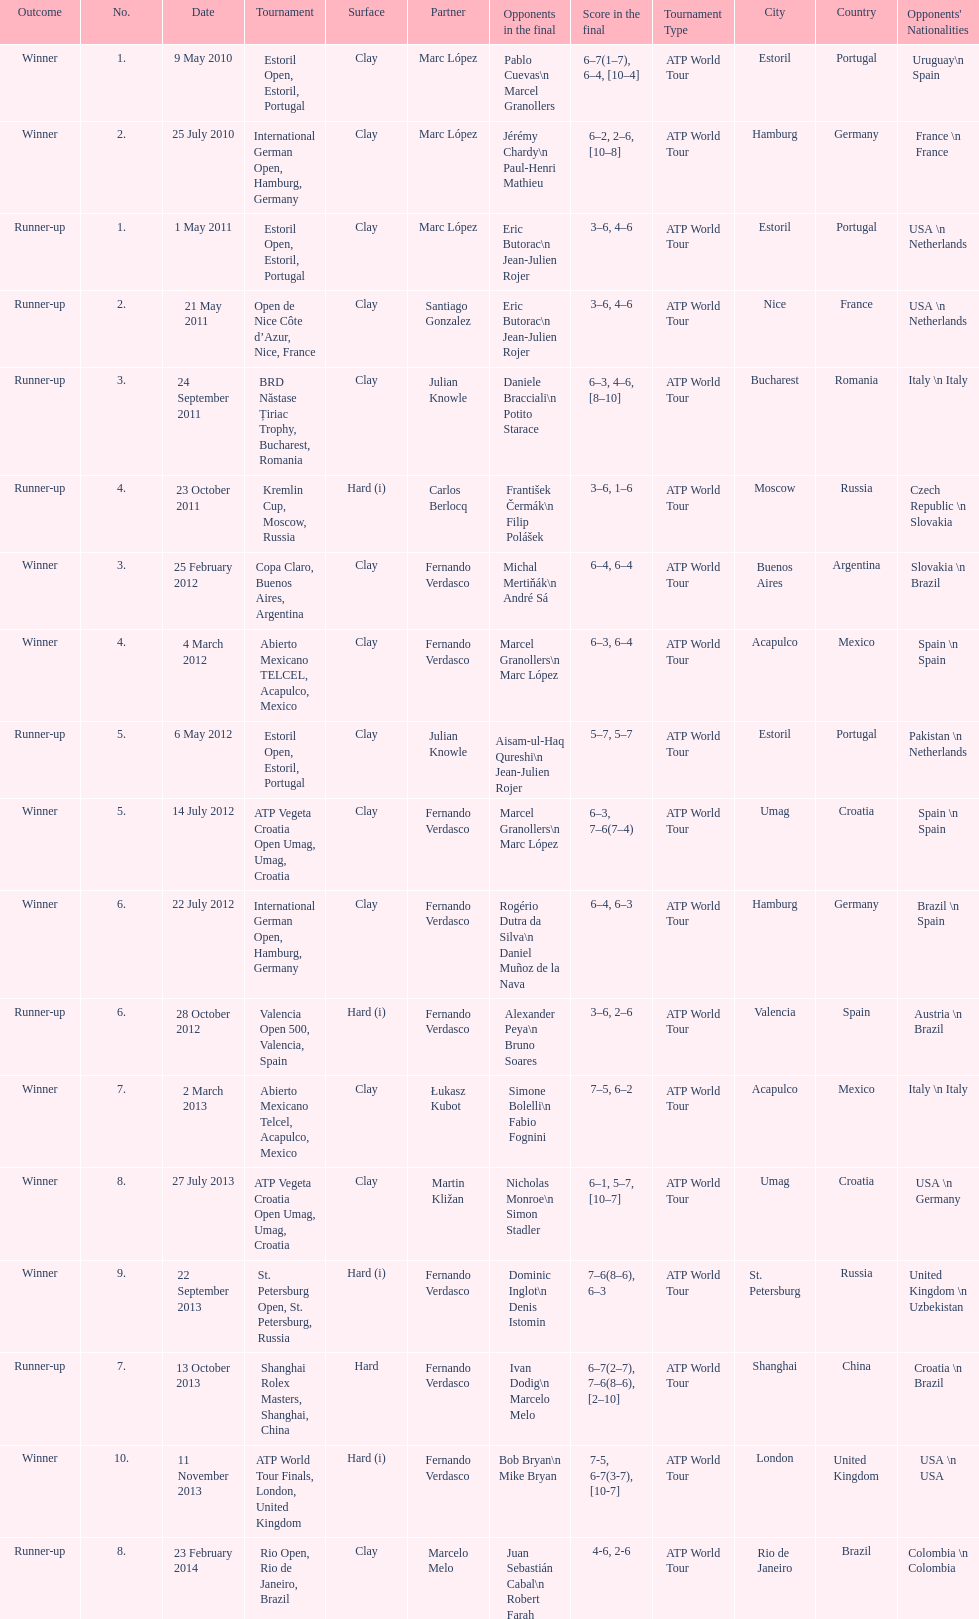What is the number of times a hard surface was used? 5. 